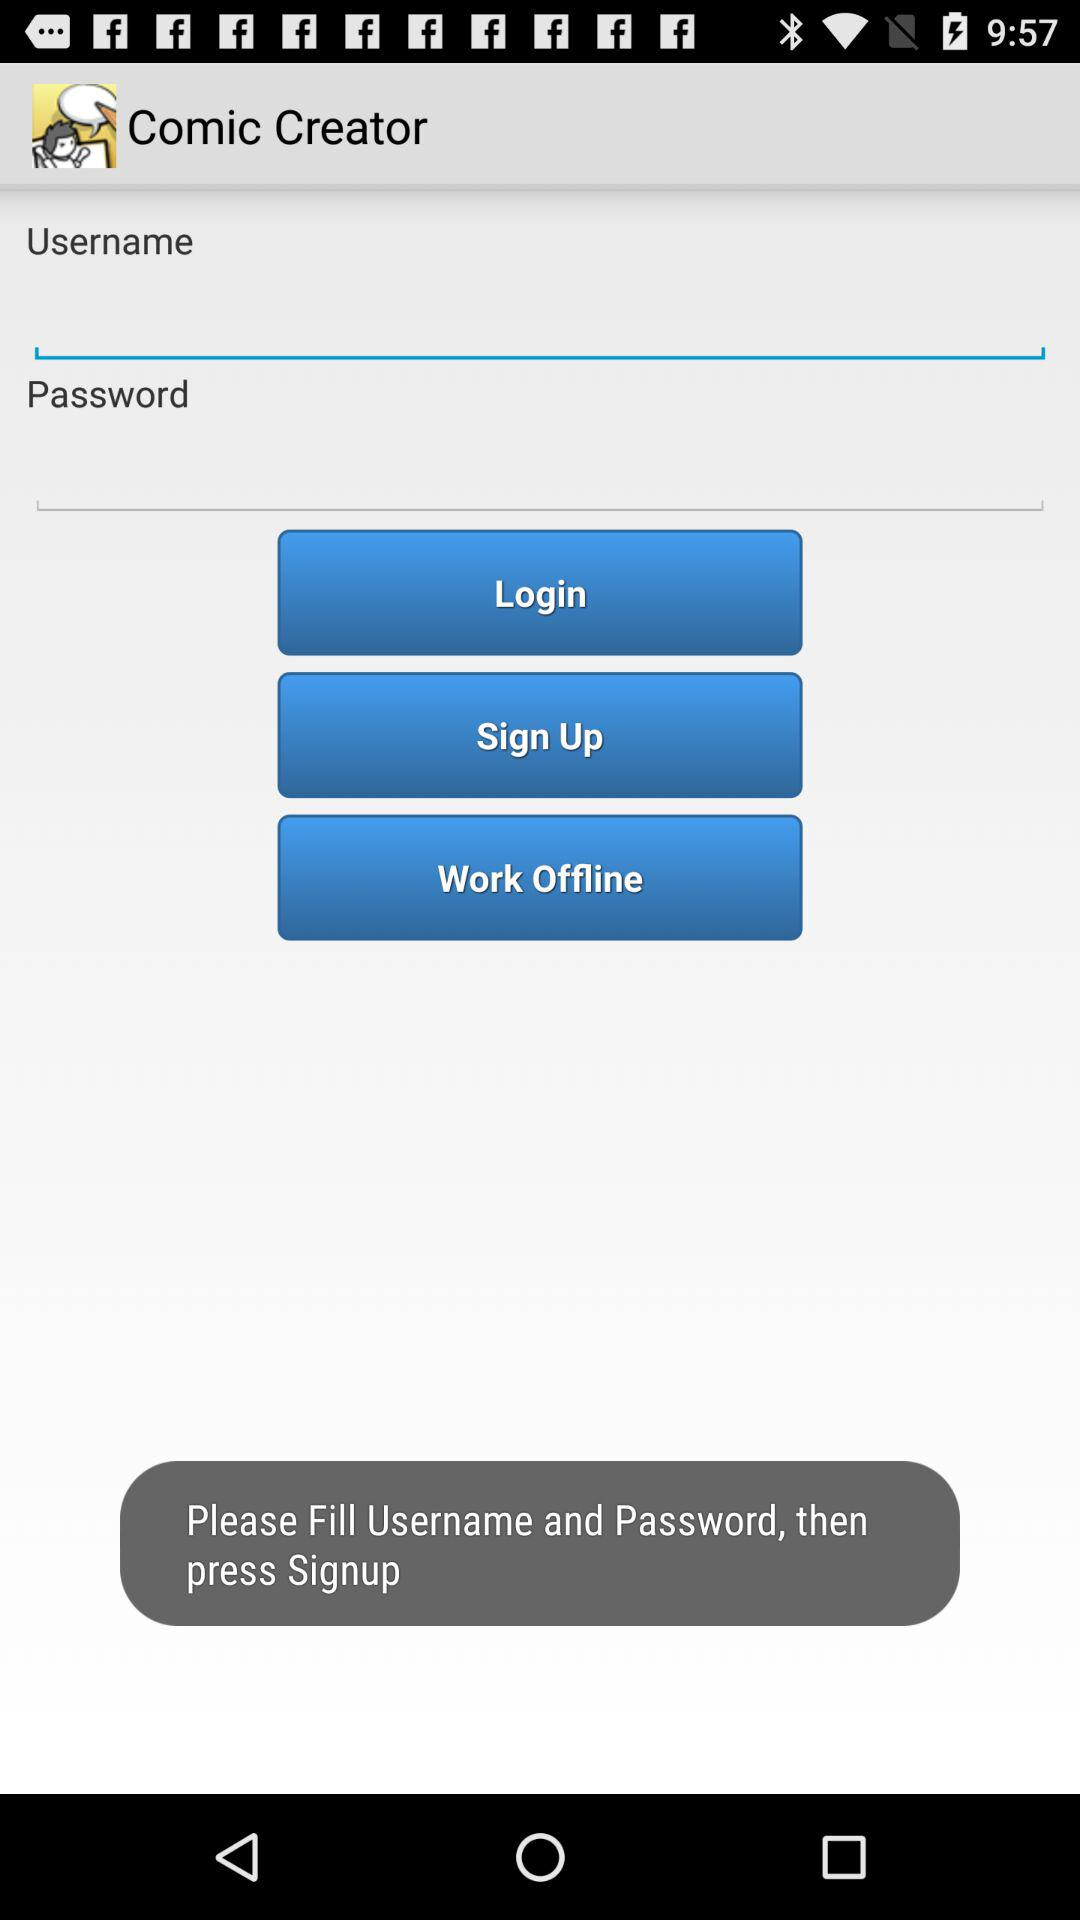What is the name of the application? The name of the application is "Comic Creator". 